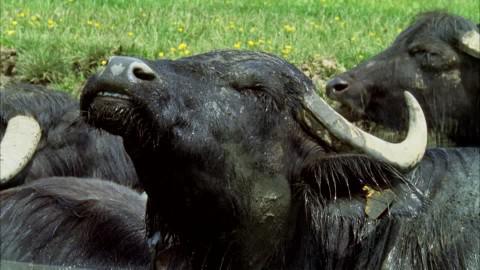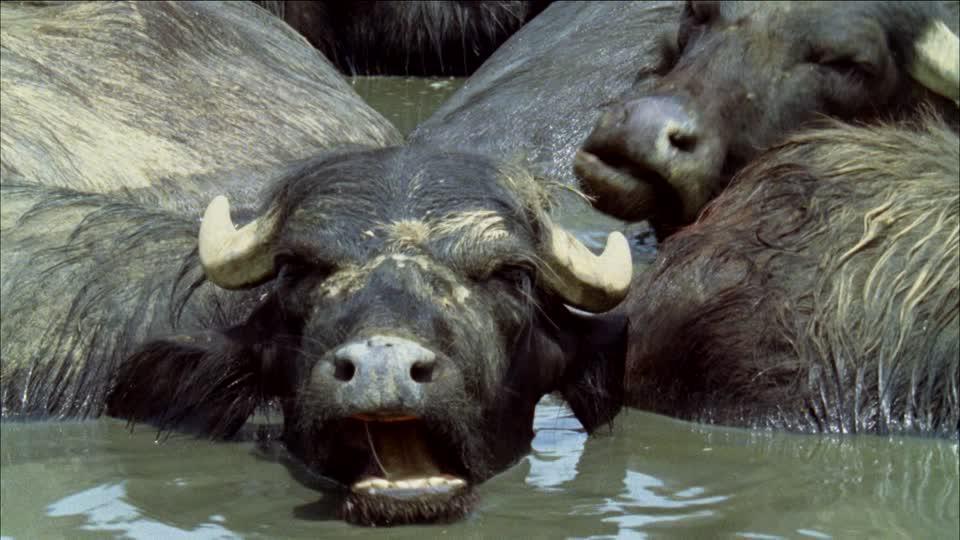The first image is the image on the left, the second image is the image on the right. Examine the images to the left and right. Is the description "Some water buffalos are in the water." accurate? Answer yes or no. Yes. The first image is the image on the left, the second image is the image on the right. Assess this claim about the two images: "At least one image includes a water buffalo in chin-deep water, and the left image includes water buffalo and green grass.". Correct or not? Answer yes or no. Yes. 